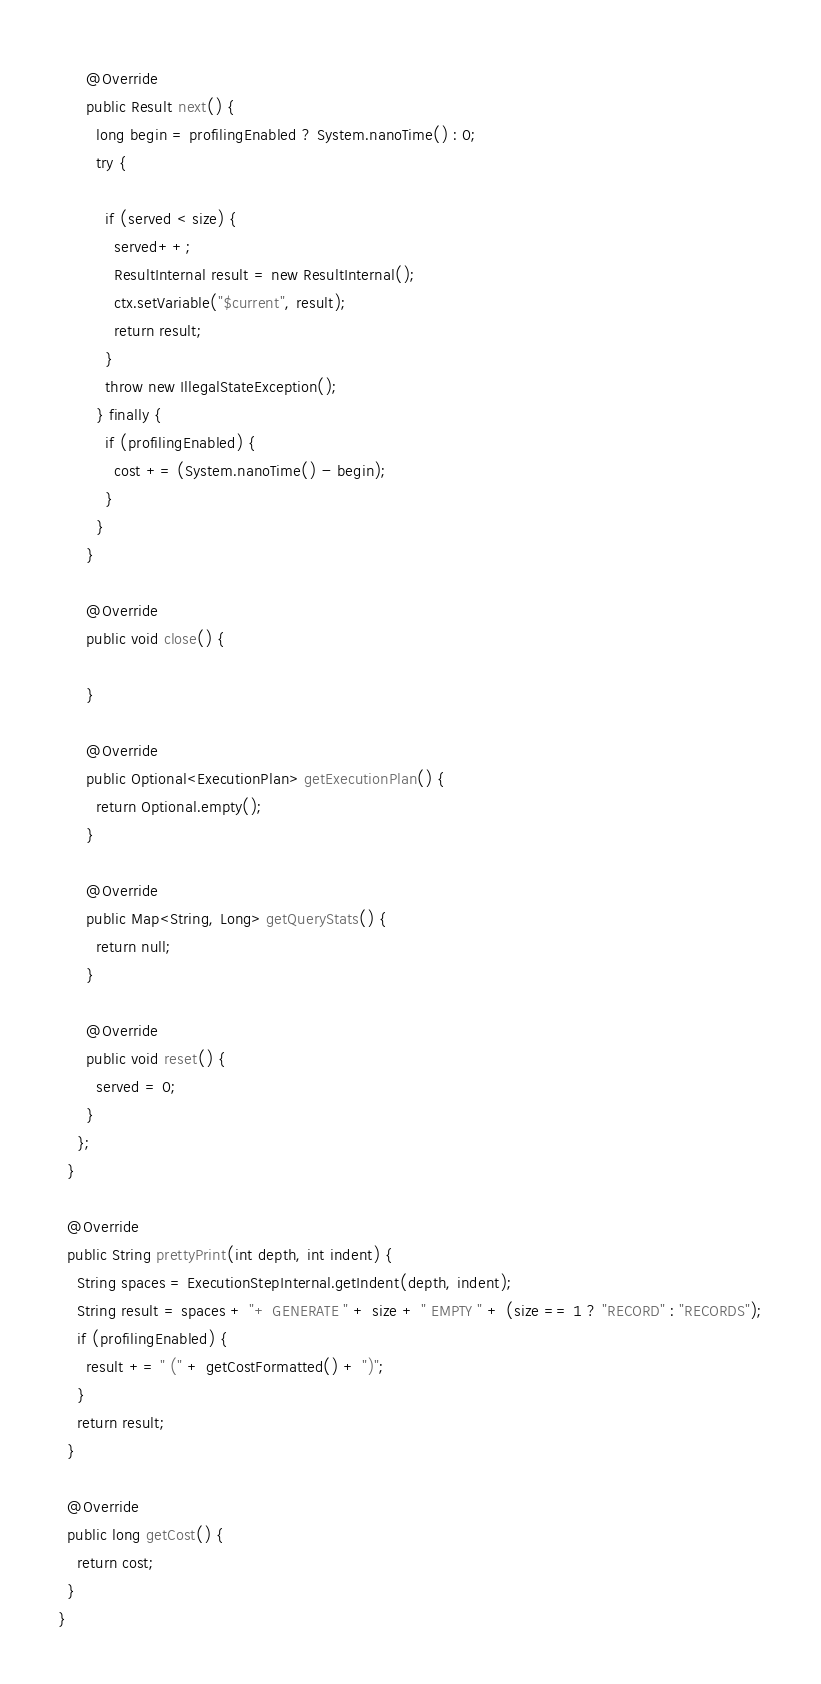Convert code to text. <code><loc_0><loc_0><loc_500><loc_500><_Java_>
      @Override
      public Result next() {
        long begin = profilingEnabled ? System.nanoTime() : 0;
        try {

          if (served < size) {
            served++;
            ResultInternal result = new ResultInternal();
            ctx.setVariable("$current", result);
            return result;
          }
          throw new IllegalStateException();
        } finally {
          if (profilingEnabled) {
            cost += (System.nanoTime() - begin);
          }
        }
      }

      @Override
      public void close() {

      }

      @Override
      public Optional<ExecutionPlan> getExecutionPlan() {
        return Optional.empty();
      }

      @Override
      public Map<String, Long> getQueryStats() {
        return null;
      }

      @Override
      public void reset() {
        served = 0;
      }
    };
  }

  @Override
  public String prettyPrint(int depth, int indent) {
    String spaces = ExecutionStepInternal.getIndent(depth, indent);
    String result = spaces + "+ GENERATE " + size + " EMPTY " + (size == 1 ? "RECORD" : "RECORDS");
    if (profilingEnabled) {
      result += " (" + getCostFormatted() + ")";
    }
    return result;
  }

  @Override
  public long getCost() {
    return cost;
  }
}
</code> 